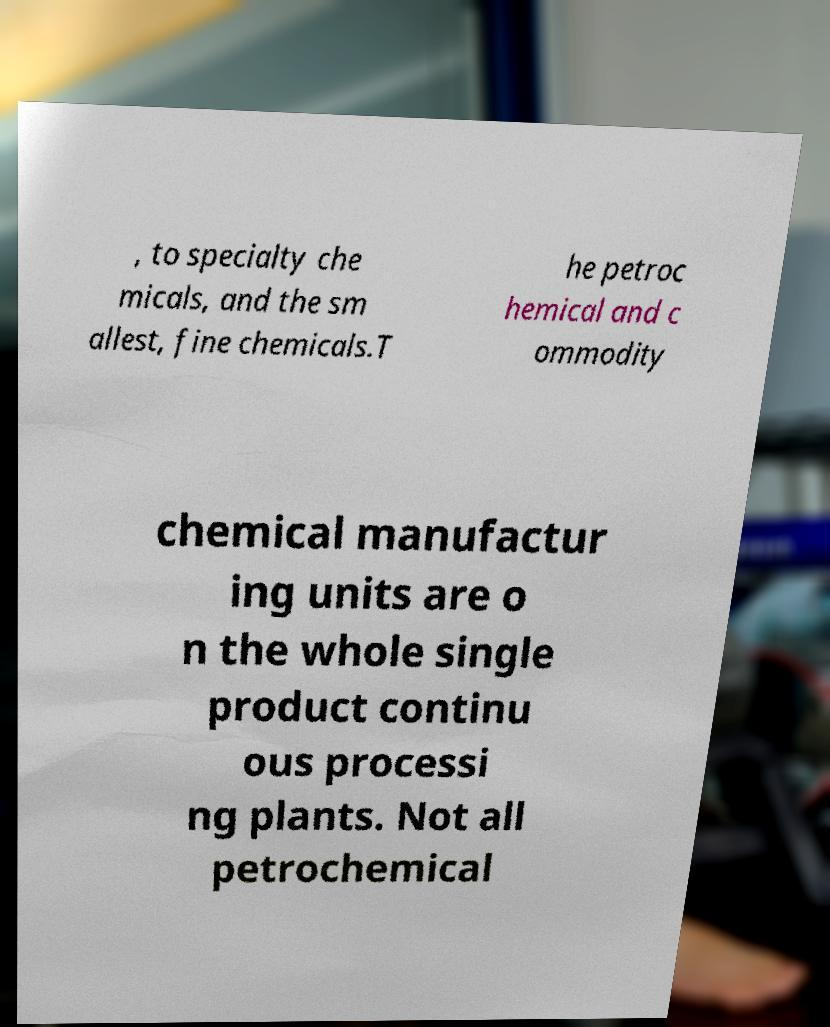Could you assist in decoding the text presented in this image and type it out clearly? , to specialty che micals, and the sm allest, fine chemicals.T he petroc hemical and c ommodity chemical manufactur ing units are o n the whole single product continu ous processi ng plants. Not all petrochemical 